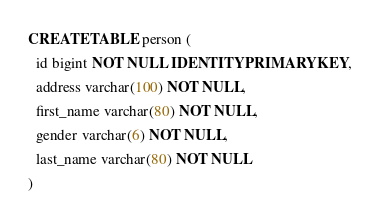Convert code to text. <code><loc_0><loc_0><loc_500><loc_500><_SQL_>CREATE TABLE person (
  id bigint NOT NULL IDENTITY PRIMARY KEY,
  address varchar(100) NOT NULL,
  first_name varchar(80) NOT NULL,
  gender varchar(6) NOT NULL,
  last_name varchar(80) NOT NULL
) </code> 